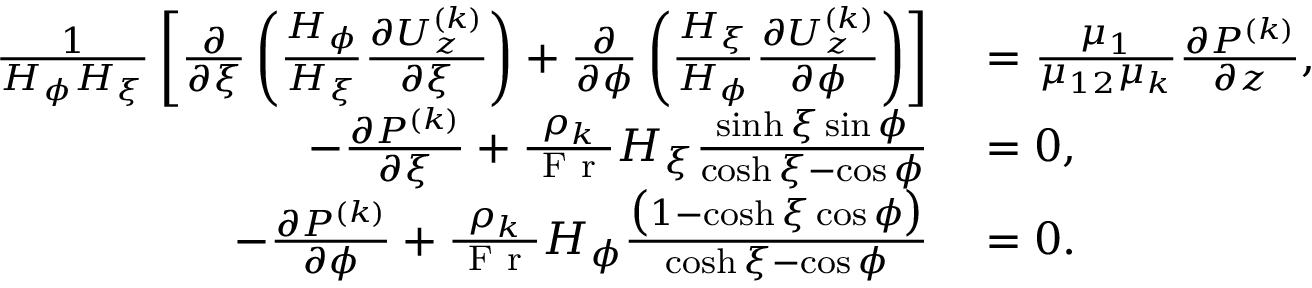<formula> <loc_0><loc_0><loc_500><loc_500>\begin{array} { r l } { \frac { 1 } { H _ { \phi } H _ { \xi } } \left [ \frac { \partial } { \partial \xi } \left ( \frac { H _ { \phi } } { H _ { \xi } } \frac { \partial U _ { z } ^ { ( k ) } } { \partial \xi } \right ) + \frac { \partial } { \partial \phi } \left ( \frac { H _ { \xi } } { H _ { \phi } } \frac { \partial U _ { z } ^ { ( k ) } } { \partial \phi } \right ) \right ] } & = \frac { \mu _ { 1 } } { \mu _ { 1 2 } \mu _ { k } } \frac { \partial P ^ { ( k ) } } { \partial z } , } \\ { - \frac { \partial P ^ { ( k ) } } { \partial \xi } + \frac { \rho _ { k } } { F r } H _ { \xi } \frac { \sinh \xi \sin \phi } { \cosh \xi - \cos \phi } } & = 0 , } \\ { - \frac { \partial P ^ { ( k ) } } { \partial \phi } + \frac { \rho _ { k } } { F r } H _ { \phi } \frac { \left ( 1 - \cosh \xi \cos \phi \right ) } { \cosh \xi - \cos \phi } } & = 0 . } \end{array}</formula> 